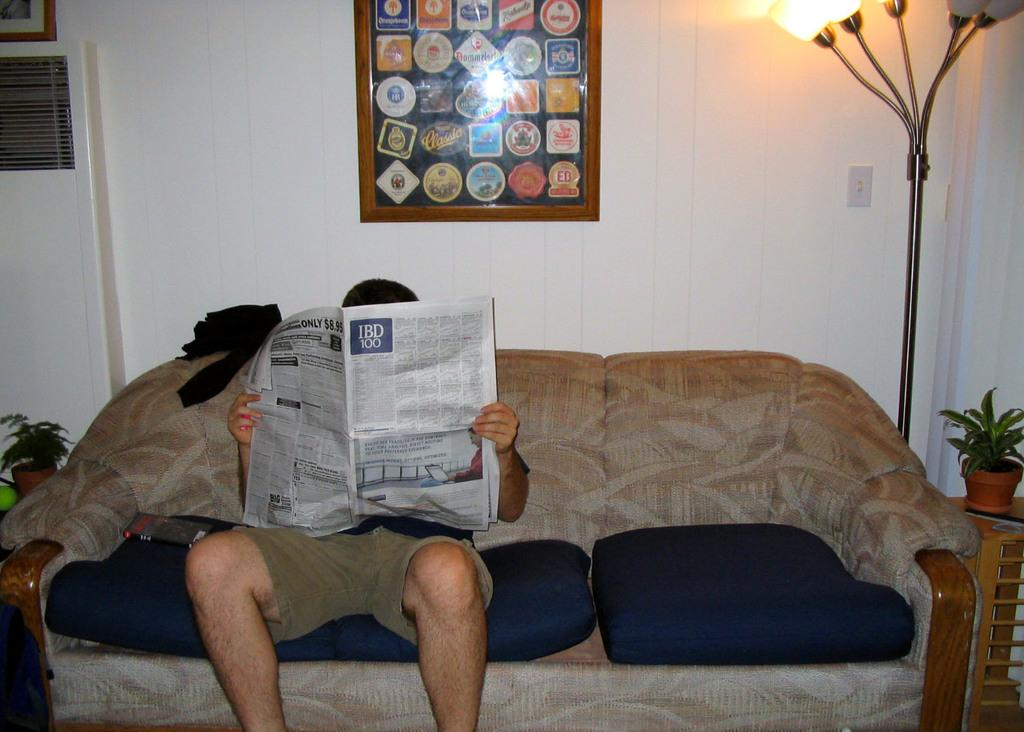What is the person in the image doing? The person is sitting on a couch and reading a newspaper. What can be seen in the background of the image? There is a wall with a photo frame in the background. What is the person surrounded by? The person is surrounded by a few objects. What type of map is the person using to read the newspaper in the image? There is no map present in the image, and the person is reading a newspaper, not using a map. 